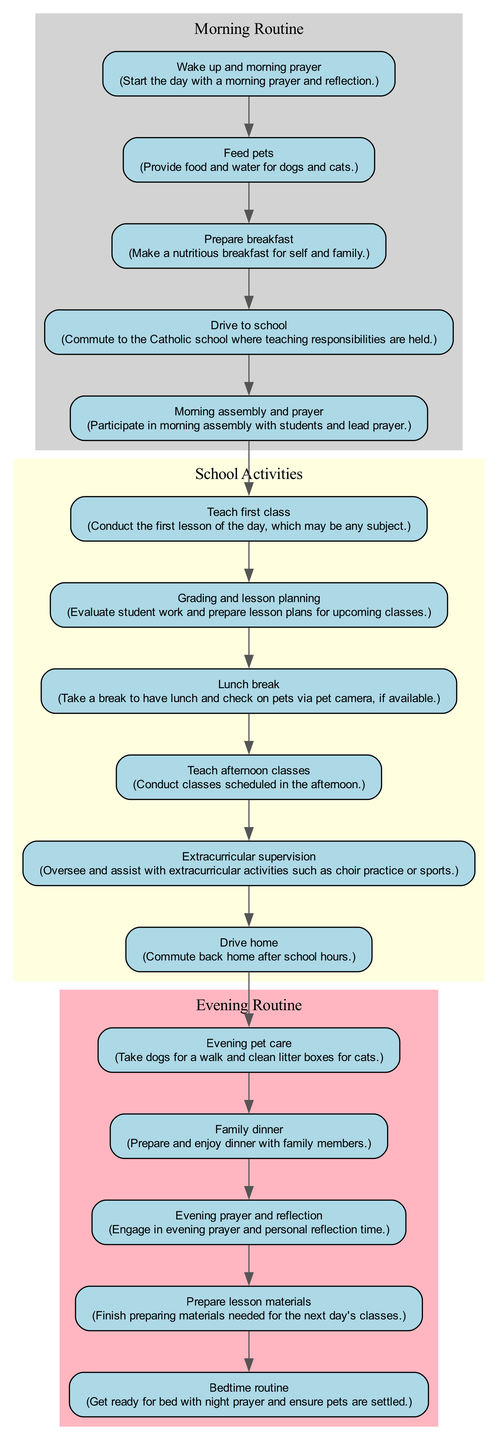What is the first activity of the day? The first activity in the diagram is "Wake up and morning prayer," which is listed as the initial node before any other activities.
Answer: Wake up and morning prayer How many nodes are categorized under evening routine? In the evening routine section, there are five activities listed in the diagram, which are all contained within the cluster labeled 'Evening Routine.'
Answer: 5 What occurs immediately after the lunch break? The diagram shows that the next activity following "Lunch break" is "Teach afternoon classes," indicating the flow from one activity to the next.
Answer: Teach afternoon classes Which activities are included in the school activities category? The school activities consist of five activities shown in the yellow cluster, specifically: "Morning assembly and prayer," "Teach first class," "Grading and lesson planning," "Lunch break," and "Teach afternoon classes."
Answer: Morning assembly and prayer, Teach first class, Grading and lesson planning, Lunch break, Teach afternoon classes What is the last activity of the day? The final activity in the diagram is "Bedtime routine," which is the last node reached after completing all other activities throughout the day.
Answer: Bedtime routine What is the relationship between "Prepare breakfast" and "Drive to school"? The diagram shows a direct sequential relationship where "Prepare breakfast" leads to "Drive to school," indicating that breakfast preparation is followed by the school commute.
Answer: Prepare breakfast leads to Drive to school How many total activities are tracked throughout the day according to the diagram? The diagram outlines a total of 16 distinct activities that reflect the daily schedule of the teacher and pet owner, from morning prayers to bedtime routines.
Answer: 16 What is the primary focus of the first cluster in the diagram? The first cluster is labeled "Morning Routine," which encompasses activities that comprise the initial part of the day, including prayer, feeding pets, and preparing breakfast.
Answer: Morning Routine 